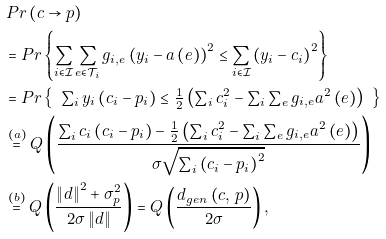<formula> <loc_0><loc_0><loc_500><loc_500>& \, P r \left ( c \rightarrow p \right ) \\ & = P r \left \{ \sum _ { i \in \mathcal { I } } \sum _ { \substack { e \in \mathcal { T } _ { i } } } g _ { i , e } \left ( y _ { i } - a \left ( e \right ) \right ) ^ { 2 } \leq \sum _ { i \in \mathcal { I } } \left ( y _ { i } - c _ { i } \right ) ^ { 2 } \right \} \\ & = P r \left \{ \begin{array} { c } \sum _ { i } y _ { i } \left ( c _ { i } - p _ { i } \right ) \leq \frac { 1 } { 2 } \left ( \sum _ { i } c _ { i } ^ { 2 } - \sum _ { i } \sum _ { \substack { e } } g _ { i , e } a ^ { 2 } \left ( e \right ) \right ) \end{array} \right \} \\ & \stackrel { ( a ) } { = } Q \left ( \frac { \sum _ { i } c _ { i } \left ( c _ { i } - p _ { i } \right ) - \frac { 1 } { 2 } \left ( \sum _ { i } c _ { i } ^ { 2 } - \sum _ { i } \sum _ { \substack { e } } g _ { i , e } a ^ { 2 } \left ( e \right ) \right ) } { \sigma \sqrt { \sum _ { i } \left ( c _ { i } - p _ { i } \right ) ^ { 2 } } } \right ) \\ & \stackrel { ( b ) } { = } Q \left ( \frac { \left \| d \right \| ^ { 2 } + \sigma _ { p } ^ { 2 } } { 2 \sigma \left \| d \right \| } \right ) = Q \left ( \frac { d _ { g e n } \left ( c , \, p \right ) } { 2 \sigma } \right ) ,</formula> 